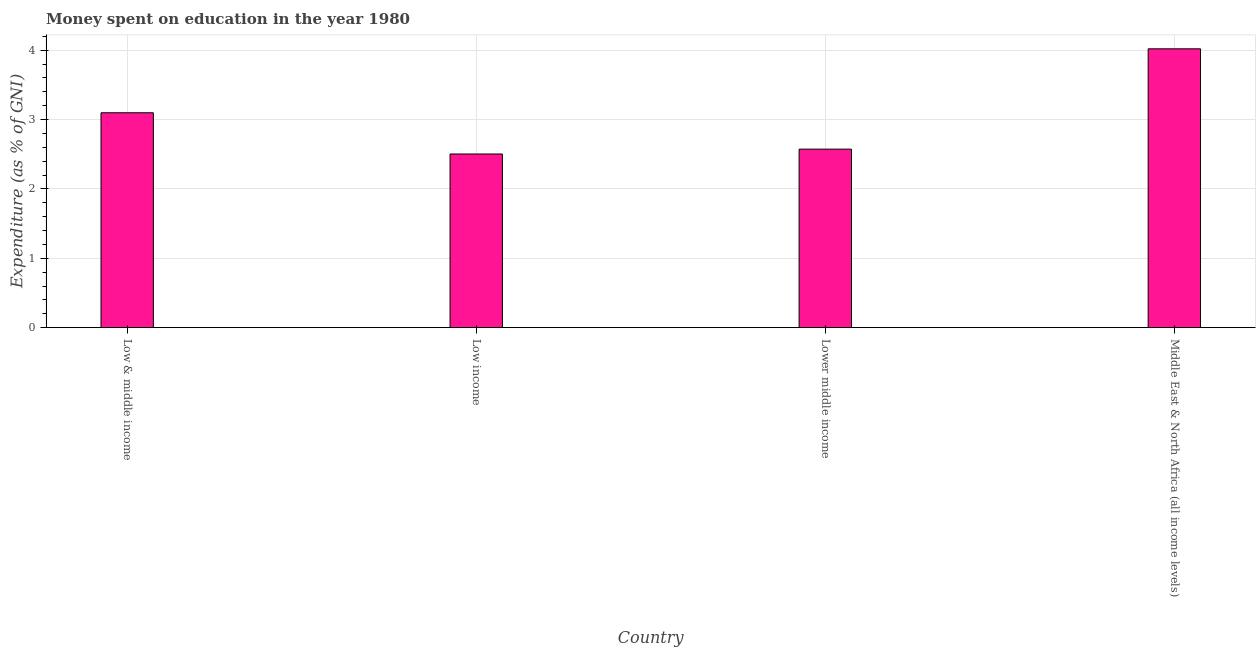Does the graph contain any zero values?
Ensure brevity in your answer.  No. What is the title of the graph?
Your answer should be very brief. Money spent on education in the year 1980. What is the label or title of the Y-axis?
Keep it short and to the point. Expenditure (as % of GNI). What is the expenditure on education in Low & middle income?
Ensure brevity in your answer.  3.1. Across all countries, what is the maximum expenditure on education?
Keep it short and to the point. 4.02. Across all countries, what is the minimum expenditure on education?
Keep it short and to the point. 2.5. In which country was the expenditure on education maximum?
Provide a short and direct response. Middle East & North Africa (all income levels). What is the sum of the expenditure on education?
Keep it short and to the point. 12.2. What is the difference between the expenditure on education in Low income and Middle East & North Africa (all income levels)?
Ensure brevity in your answer.  -1.52. What is the average expenditure on education per country?
Your answer should be compact. 3.05. What is the median expenditure on education?
Provide a succinct answer. 2.84. In how many countries, is the expenditure on education greater than 2 %?
Make the answer very short. 4. What is the ratio of the expenditure on education in Low income to that in Lower middle income?
Offer a very short reply. 0.97. Is the expenditure on education in Low income less than that in Lower middle income?
Provide a short and direct response. Yes. What is the difference between the highest and the second highest expenditure on education?
Offer a terse response. 0.92. What is the difference between the highest and the lowest expenditure on education?
Give a very brief answer. 1.52. Are the values on the major ticks of Y-axis written in scientific E-notation?
Give a very brief answer. No. What is the Expenditure (as % of GNI) in Low & middle income?
Your response must be concise. 3.1. What is the Expenditure (as % of GNI) in Low income?
Make the answer very short. 2.5. What is the Expenditure (as % of GNI) of Lower middle income?
Offer a terse response. 2.57. What is the Expenditure (as % of GNI) in Middle East & North Africa (all income levels)?
Make the answer very short. 4.02. What is the difference between the Expenditure (as % of GNI) in Low & middle income and Low income?
Provide a succinct answer. 0.59. What is the difference between the Expenditure (as % of GNI) in Low & middle income and Lower middle income?
Offer a very short reply. 0.52. What is the difference between the Expenditure (as % of GNI) in Low & middle income and Middle East & North Africa (all income levels)?
Offer a terse response. -0.92. What is the difference between the Expenditure (as % of GNI) in Low income and Lower middle income?
Your answer should be very brief. -0.07. What is the difference between the Expenditure (as % of GNI) in Low income and Middle East & North Africa (all income levels)?
Your answer should be very brief. -1.52. What is the difference between the Expenditure (as % of GNI) in Lower middle income and Middle East & North Africa (all income levels)?
Make the answer very short. -1.45. What is the ratio of the Expenditure (as % of GNI) in Low & middle income to that in Low income?
Ensure brevity in your answer.  1.24. What is the ratio of the Expenditure (as % of GNI) in Low & middle income to that in Lower middle income?
Provide a short and direct response. 1.2. What is the ratio of the Expenditure (as % of GNI) in Low & middle income to that in Middle East & North Africa (all income levels)?
Your answer should be very brief. 0.77. What is the ratio of the Expenditure (as % of GNI) in Low income to that in Lower middle income?
Make the answer very short. 0.97. What is the ratio of the Expenditure (as % of GNI) in Low income to that in Middle East & North Africa (all income levels)?
Make the answer very short. 0.62. What is the ratio of the Expenditure (as % of GNI) in Lower middle income to that in Middle East & North Africa (all income levels)?
Offer a terse response. 0.64. 